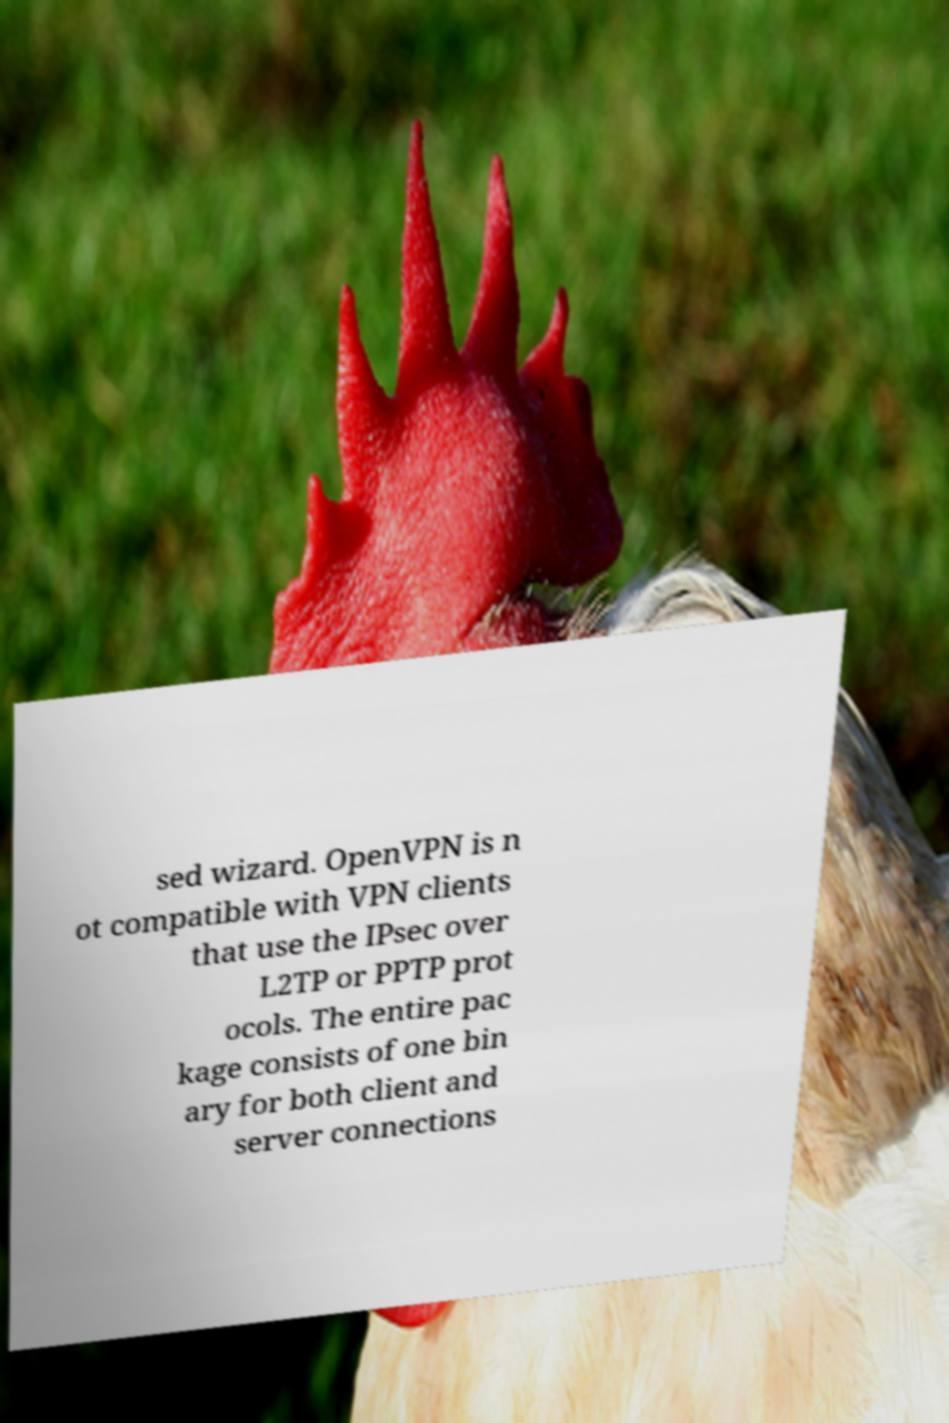For documentation purposes, I need the text within this image transcribed. Could you provide that? sed wizard. OpenVPN is n ot compatible with VPN clients that use the IPsec over L2TP or PPTP prot ocols. The entire pac kage consists of one bin ary for both client and server connections 